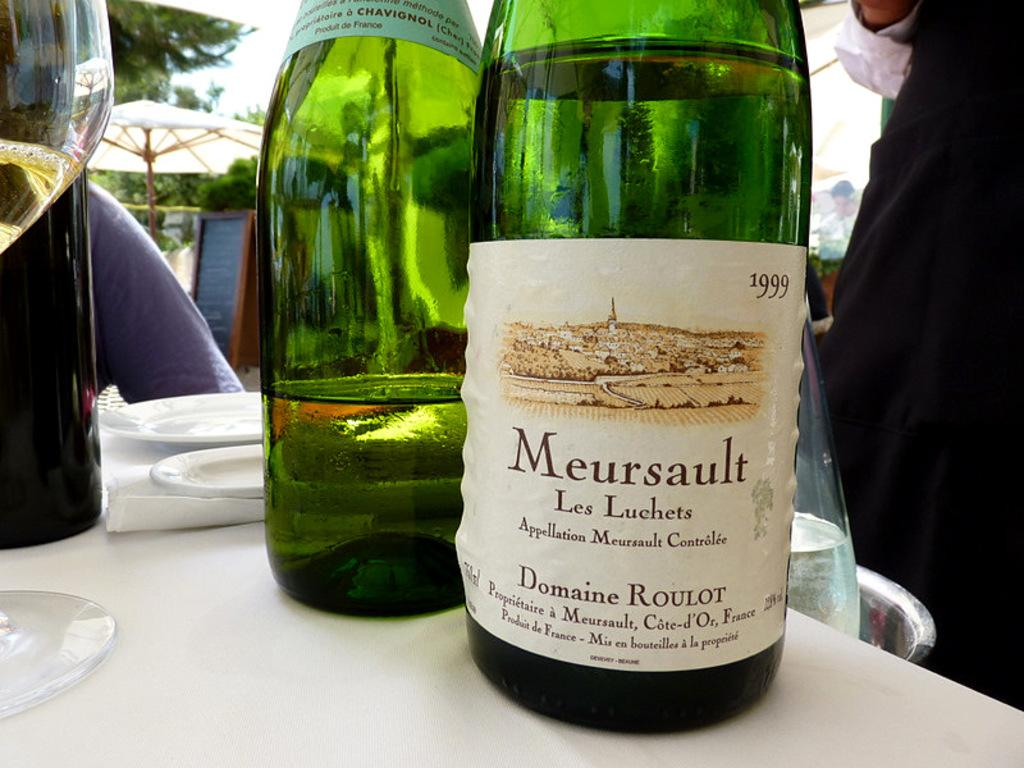<image>
Render a clear and concise summary of the photo. A bottle of Meursault from 1999 is sitting on a table outside. 